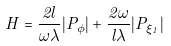Convert formula to latex. <formula><loc_0><loc_0><loc_500><loc_500>H = \frac { 2 l } { \omega \lambda } | P _ { \phi } | + \frac { 2 \omega } { l \lambda } | P _ { \xi _ { 1 } } |</formula> 